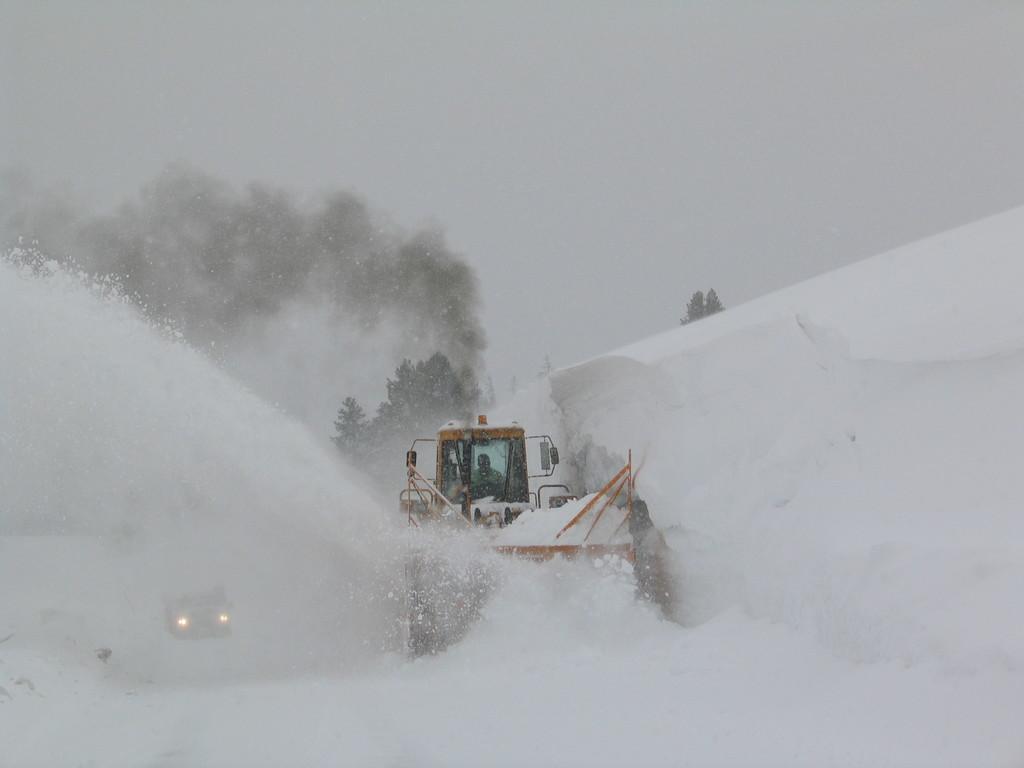How would you summarize this image in a sentence or two? In the picture we can see a snow surface on it, we can see a snow remover vehicle, removing the snow just beside it, we can see a vehicle with headlights on and on the other side, we can see a snow hill and in the background we can see some trees and sky. 